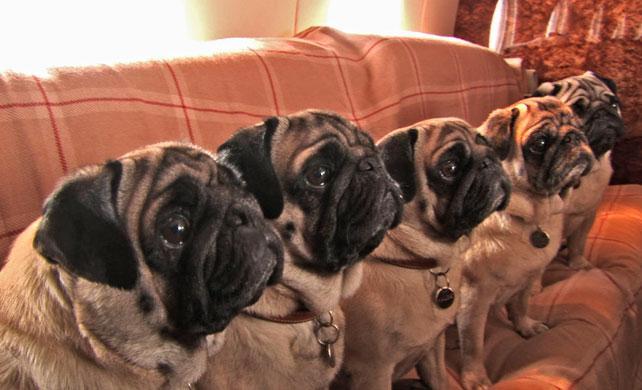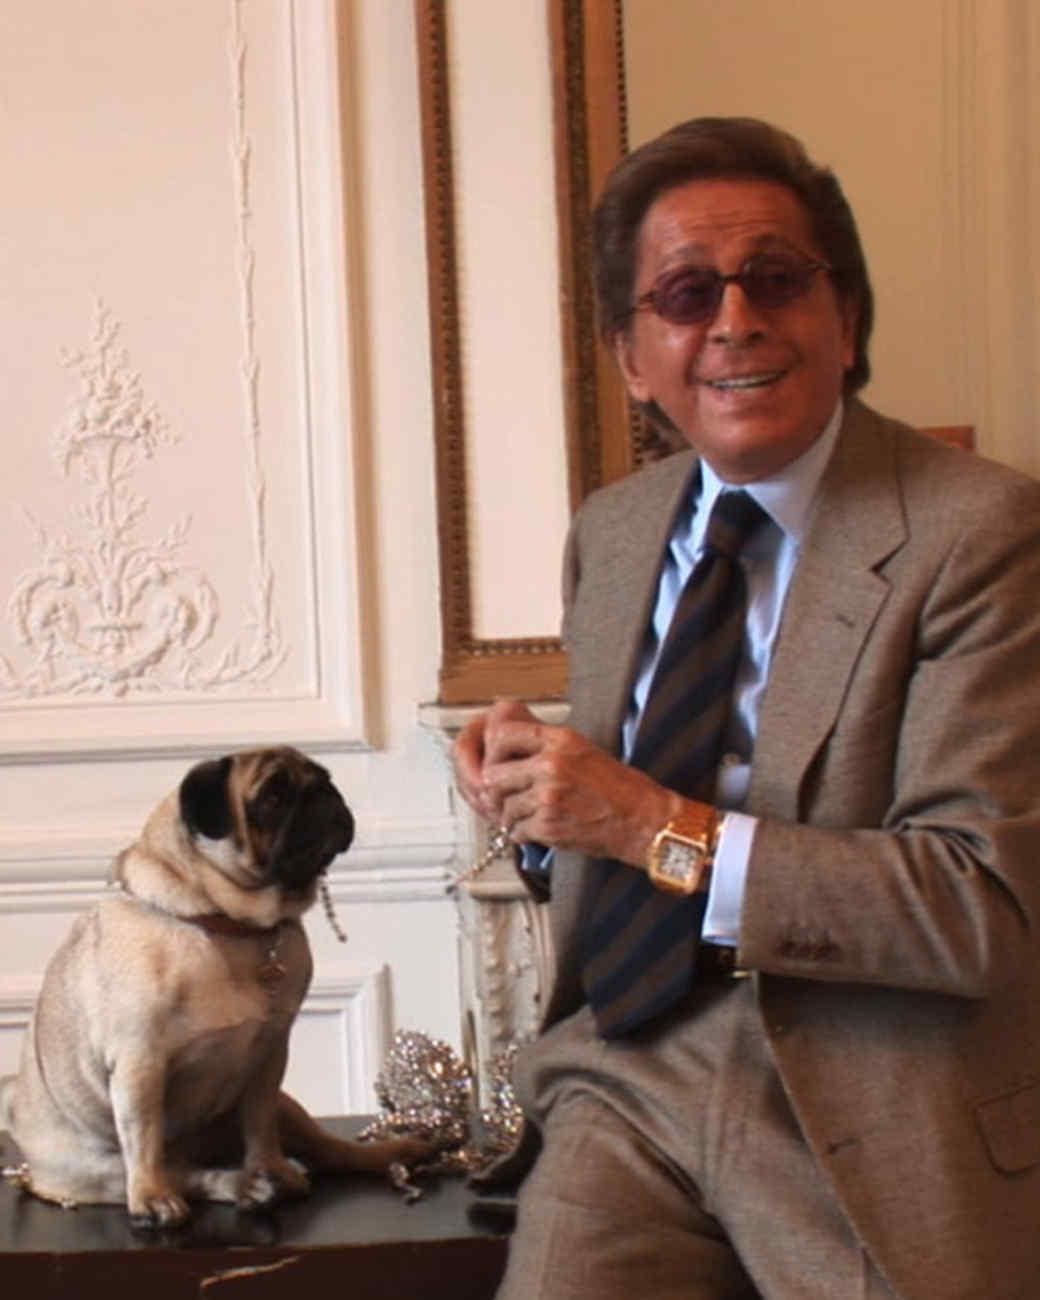The first image is the image on the left, the second image is the image on the right. Given the left and right images, does the statement "The right image contains no more than one dog." hold true? Answer yes or no. Yes. 